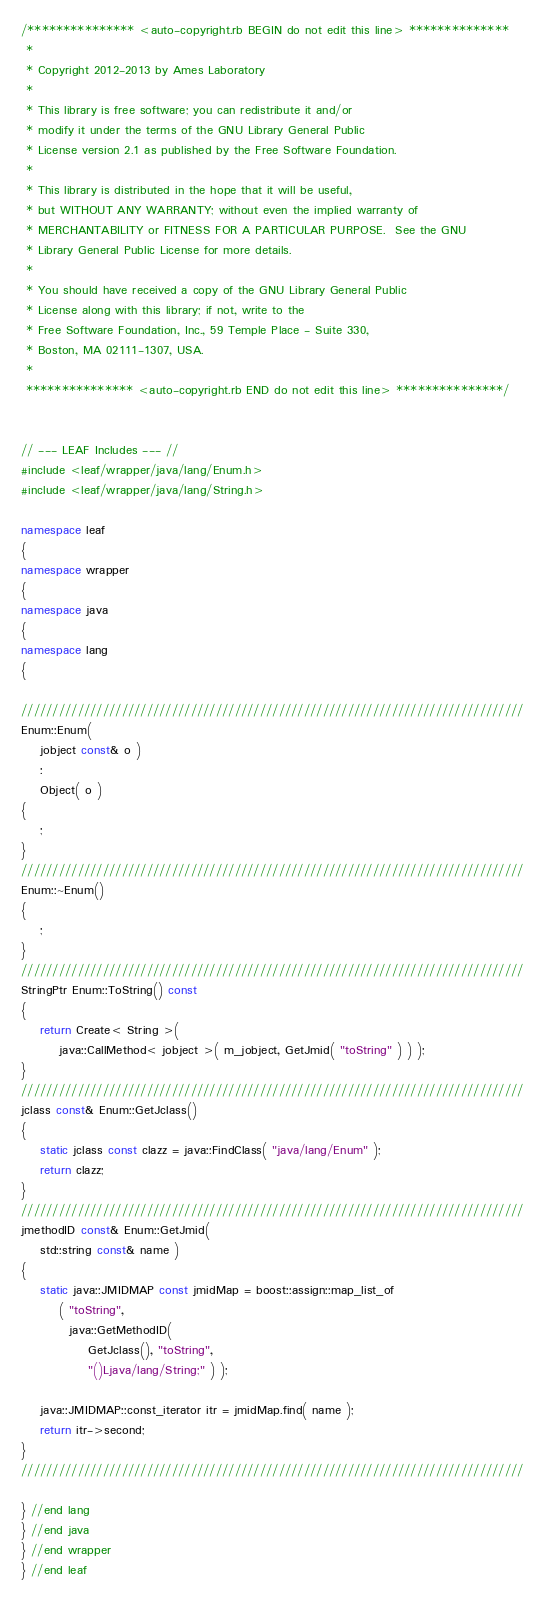Convert code to text. <code><loc_0><loc_0><loc_500><loc_500><_C++_>/*************** <auto-copyright.rb BEGIN do not edit this line> **************
 *
 * Copyright 2012-2013 by Ames Laboratory
 *
 * This library is free software; you can redistribute it and/or
 * modify it under the terms of the GNU Library General Public
 * License version 2.1 as published by the Free Software Foundation.
 *
 * This library is distributed in the hope that it will be useful,
 * but WITHOUT ANY WARRANTY; without even the implied warranty of
 * MERCHANTABILITY or FITNESS FOR A PARTICULAR PURPOSE.  See the GNU
 * Library General Public License for more details.
 *
 * You should have received a copy of the GNU Library General Public
 * License along with this library; if not, write to the
 * Free Software Foundation, Inc., 59 Temple Place - Suite 330,
 * Boston, MA 02111-1307, USA.
 *
 *************** <auto-copyright.rb END do not edit this line> ***************/


// --- LEAF Includes --- //
#include <leaf/wrapper/java/lang/Enum.h>
#include <leaf/wrapper/java/lang/String.h>

namespace leaf
{
namespace wrapper
{
namespace java
{
namespace lang
{

////////////////////////////////////////////////////////////////////////////////
Enum::Enum(
    jobject const& o )
    :
    Object( o )
{
    ;
}
////////////////////////////////////////////////////////////////////////////////
Enum::~Enum()
{
    ;
}
////////////////////////////////////////////////////////////////////////////////
StringPtr Enum::ToString() const
{
    return Create< String >(
        java::CallMethod< jobject >( m_jobject, GetJmid( "toString" ) ) );
}
////////////////////////////////////////////////////////////////////////////////
jclass const& Enum::GetJclass()
{
    static jclass const clazz = java::FindClass( "java/lang/Enum" );
    return clazz;
}
////////////////////////////////////////////////////////////////////////////////
jmethodID const& Enum::GetJmid(
    std::string const& name )
{
    static java::JMIDMAP const jmidMap = boost::assign::map_list_of
        ( "toString",
          java::GetMethodID(
              GetJclass(), "toString",
              "()Ljava/lang/String;" ) );

    java::JMIDMAP::const_iterator itr = jmidMap.find( name );
    return itr->second;
}
////////////////////////////////////////////////////////////////////////////////

} //end lang
} //end java
} //end wrapper
} //end leaf
</code> 